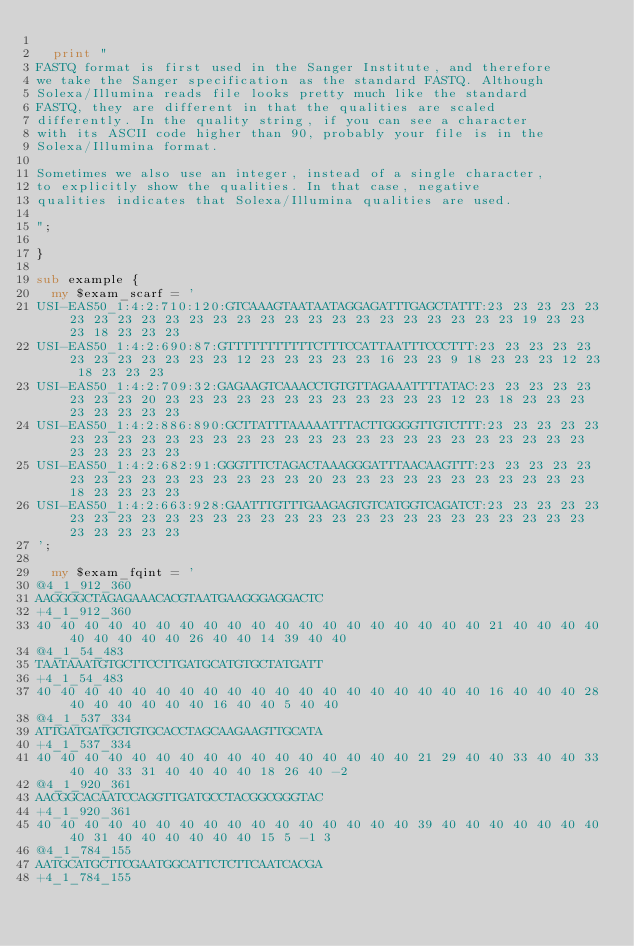<code> <loc_0><loc_0><loc_500><loc_500><_Perl_>
	print "
FASTQ format is first used in the Sanger Institute, and therefore
we take the Sanger specification as the standard FASTQ. Although
Solexa/Illumina reads file looks pretty much like the standard
FASTQ, they are different in that the qualities are scaled
differently. In the quality string, if you can see a character
with its ASCII code higher than 90, probably your file is in the
Solexa/Illumina format.

Sometimes we also use an integer, instead of a single character,
to explicitly show the qualities. In that case, negative
qualities indicates that Solexa/Illumina qualities are used.

";

}

sub example {
	my $exam_scarf = '
USI-EAS50_1:4:2:710:120:GTCAAAGTAATAATAGGAGATTTGAGCTATTT:23 23 23 23 23 23 23 23 23 23 23 23 23 23 23 23 23 23 23 23 23 23 23 23 19 23 23 23 18 23 23 23
USI-EAS50_1:4:2:690:87:GTTTTTTTTTTTCTTTCCATTAATTTCCCTTT:23 23 23 23 23 23 23 23 23 23 23 23 12 23 23 23 23 23 16 23 23 9 18 23 23 23 12 23 18 23 23 23
USI-EAS50_1:4:2:709:32:GAGAAGTCAAACCTGTGTTAGAAATTTTATAC:23 23 23 23 23 23 23 23 20 23 23 23 23 23 23 23 23 23 23 23 23 12 23 18 23 23 23 23 23 23 23 23
USI-EAS50_1:4:2:886:890:GCTTATTTAAAAATTTACTTGGGGTTGTCTTT:23 23 23 23 23 23 23 23 23 23 23 23 23 23 23 23 23 23 23 23 23 23 23 23 23 23 23 23 23 23 23 23
USI-EAS50_1:4:2:682:91:GGGTTTCTAGACTAAAGGGATTTAACAAGTTT:23 23 23 23 23 23 23 23 23 23 23 23 23 23 23 20 23 23 23 23 23 23 23 23 23 23 23 18 23 23 23 23
USI-EAS50_1:4:2:663:928:GAATTTGTTTGAAGAGTGTCATGGTCAGATCT:23 23 23 23 23 23 23 23 23 23 23 23 23 23 23 23 23 23 23 23 23 23 23 23 23 23 23 23 23 23 23 23
';

	my $exam_fqint = '
@4_1_912_360
AAGGGGCTAGAGAAACACGTAATGAAGGGAGGACTC
+4_1_912_360
40 40 40 40 40 40 40 40 40 40 40 40 40 40 40 40 40 40 40 21 40 40 40 40 40 40 40 40 40 26 40 40 14 39 40 40
@4_1_54_483
TAATAAATGTGCTTCCTTGATGCATGTGCTATGATT
+4_1_54_483
40 40 40 40 40 40 40 40 40 40 40 40 40 40 40 40 40 40 40 16 40 40 40 28 40 40 40 40 40 40 16 40 40 5 40 40
@4_1_537_334
ATTGATGATGCTGTGCACCTAGCAAGAAGTTGCATA
+4_1_537_334
40 40 40 40 40 40 40 40 40 40 40 40 40 40 40 40 21 29 40 40 33 40 40 33 40 40 33 31 40 40 40 40 18 26 40 -2
@4_1_920_361
AACGGCACAATCCAGGTTGATGCCTACGGCGGGTAC
+4_1_920_361
40 40 40 40 40 40 40 40 40 40 40 40 40 40 40 40 39 40 40 40 40 40 40 40 40 31 40 40 40 40 40 40 15 5 -1 3
@4_1_784_155
AATGCATGCTTCGAATGGCATTCTCTTCAATCACGA
+4_1_784_155</code> 